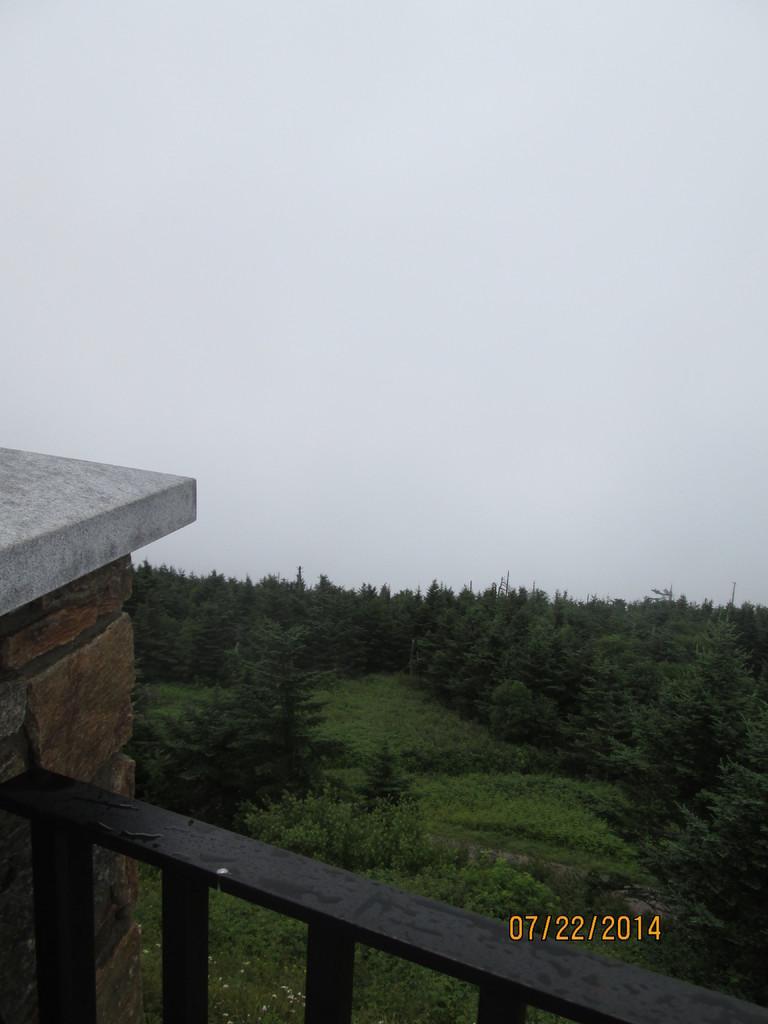Could you give a brief overview of what you see in this image? In this picture we can observe some trees. There is a black color railing. We can observe a date on the picture which is in yellow color. In the background there is a sky. 